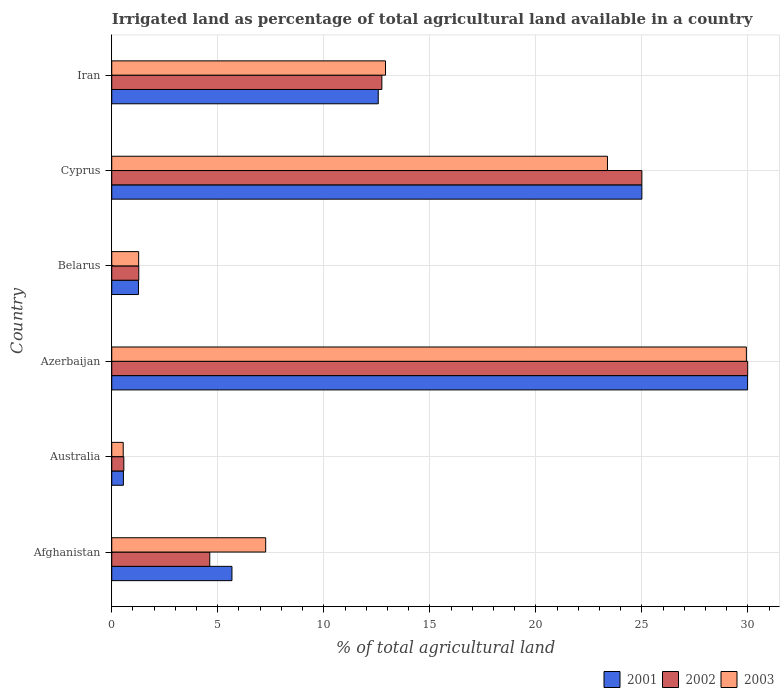How many different coloured bars are there?
Ensure brevity in your answer.  3. Are the number of bars per tick equal to the number of legend labels?
Offer a terse response. Yes. How many bars are there on the 6th tick from the bottom?
Your answer should be compact. 3. What is the label of the 3rd group of bars from the top?
Offer a very short reply. Belarus. What is the percentage of irrigated land in 2003 in Azerbaijan?
Ensure brevity in your answer.  29.93. Across all countries, what is the maximum percentage of irrigated land in 2001?
Ensure brevity in your answer.  29.99. Across all countries, what is the minimum percentage of irrigated land in 2003?
Offer a very short reply. 0.54. In which country was the percentage of irrigated land in 2001 maximum?
Ensure brevity in your answer.  Azerbaijan. What is the total percentage of irrigated land in 2003 in the graph?
Your answer should be compact. 75.29. What is the difference between the percentage of irrigated land in 2002 in Belarus and that in Cyprus?
Make the answer very short. -23.73. What is the difference between the percentage of irrigated land in 2001 in Azerbaijan and the percentage of irrigated land in 2003 in Iran?
Offer a terse response. 17.08. What is the average percentage of irrigated land in 2002 per country?
Offer a very short reply. 12.37. What is the difference between the percentage of irrigated land in 2002 and percentage of irrigated land in 2001 in Belarus?
Offer a terse response. 0.01. What is the ratio of the percentage of irrigated land in 2002 in Afghanistan to that in Iran?
Your answer should be very brief. 0.36. Is the percentage of irrigated land in 2001 in Australia less than that in Azerbaijan?
Offer a terse response. Yes. What is the difference between the highest and the second highest percentage of irrigated land in 2003?
Your answer should be very brief. 6.55. What is the difference between the highest and the lowest percentage of irrigated land in 2002?
Your answer should be compact. 29.42. Is the sum of the percentage of irrigated land in 2003 in Australia and Iran greater than the maximum percentage of irrigated land in 2002 across all countries?
Keep it short and to the point. No. What does the 2nd bar from the top in Australia represents?
Offer a very short reply. 2002. Is it the case that in every country, the sum of the percentage of irrigated land in 2001 and percentage of irrigated land in 2003 is greater than the percentage of irrigated land in 2002?
Keep it short and to the point. Yes. How many bars are there?
Give a very brief answer. 18. Are all the bars in the graph horizontal?
Provide a succinct answer. Yes. What is the difference between two consecutive major ticks on the X-axis?
Your answer should be compact. 5. Are the values on the major ticks of X-axis written in scientific E-notation?
Give a very brief answer. No. Does the graph contain any zero values?
Give a very brief answer. No. Does the graph contain grids?
Your answer should be very brief. Yes. Where does the legend appear in the graph?
Ensure brevity in your answer.  Bottom right. How many legend labels are there?
Ensure brevity in your answer.  3. What is the title of the graph?
Give a very brief answer. Irrigated land as percentage of total agricultural land available in a country. Does "2012" appear as one of the legend labels in the graph?
Offer a very short reply. No. What is the label or title of the X-axis?
Give a very brief answer. % of total agricultural land. What is the label or title of the Y-axis?
Give a very brief answer. Country. What is the % of total agricultural land in 2001 in Afghanistan?
Keep it short and to the point. 5.67. What is the % of total agricultural land in 2002 in Afghanistan?
Give a very brief answer. 4.62. What is the % of total agricultural land of 2003 in Afghanistan?
Offer a very short reply. 7.26. What is the % of total agricultural land of 2001 in Australia?
Provide a short and direct response. 0.55. What is the % of total agricultural land of 2002 in Australia?
Your answer should be compact. 0.57. What is the % of total agricultural land in 2003 in Australia?
Your answer should be very brief. 0.54. What is the % of total agricultural land of 2001 in Azerbaijan?
Offer a terse response. 29.99. What is the % of total agricultural land in 2002 in Azerbaijan?
Your response must be concise. 29.99. What is the % of total agricultural land in 2003 in Azerbaijan?
Provide a succinct answer. 29.93. What is the % of total agricultural land of 2001 in Belarus?
Your response must be concise. 1.26. What is the % of total agricultural land in 2002 in Belarus?
Keep it short and to the point. 1.27. What is the % of total agricultural land of 2003 in Belarus?
Make the answer very short. 1.27. What is the % of total agricultural land of 2001 in Cyprus?
Your response must be concise. 25. What is the % of total agricultural land in 2002 in Cyprus?
Keep it short and to the point. 25. What is the % of total agricultural land in 2003 in Cyprus?
Give a very brief answer. 23.38. What is the % of total agricultural land in 2001 in Iran?
Provide a short and direct response. 12.57. What is the % of total agricultural land in 2002 in Iran?
Offer a very short reply. 12.74. What is the % of total agricultural land in 2003 in Iran?
Make the answer very short. 12.91. Across all countries, what is the maximum % of total agricultural land in 2001?
Give a very brief answer. 29.99. Across all countries, what is the maximum % of total agricultural land of 2002?
Provide a short and direct response. 29.99. Across all countries, what is the maximum % of total agricultural land of 2003?
Your answer should be compact. 29.93. Across all countries, what is the minimum % of total agricultural land in 2001?
Your answer should be very brief. 0.55. Across all countries, what is the minimum % of total agricultural land in 2002?
Your answer should be compact. 0.57. Across all countries, what is the minimum % of total agricultural land of 2003?
Keep it short and to the point. 0.54. What is the total % of total agricultural land in 2001 in the graph?
Provide a short and direct response. 75.03. What is the total % of total agricultural land of 2002 in the graph?
Offer a terse response. 74.19. What is the total % of total agricultural land of 2003 in the graph?
Give a very brief answer. 75.29. What is the difference between the % of total agricultural land in 2001 in Afghanistan and that in Australia?
Provide a succinct answer. 5.12. What is the difference between the % of total agricultural land in 2002 in Afghanistan and that in Australia?
Keep it short and to the point. 4.05. What is the difference between the % of total agricultural land in 2003 in Afghanistan and that in Australia?
Your answer should be compact. 6.72. What is the difference between the % of total agricultural land in 2001 in Afghanistan and that in Azerbaijan?
Your answer should be compact. -24.32. What is the difference between the % of total agricultural land in 2002 in Afghanistan and that in Azerbaijan?
Keep it short and to the point. -25.37. What is the difference between the % of total agricultural land of 2003 in Afghanistan and that in Azerbaijan?
Offer a very short reply. -22.67. What is the difference between the % of total agricultural land of 2001 in Afghanistan and that in Belarus?
Provide a short and direct response. 4.41. What is the difference between the % of total agricultural land of 2002 in Afghanistan and that in Belarus?
Make the answer very short. 3.35. What is the difference between the % of total agricultural land of 2003 in Afghanistan and that in Belarus?
Make the answer very short. 5.99. What is the difference between the % of total agricultural land in 2001 in Afghanistan and that in Cyprus?
Offer a very short reply. -19.33. What is the difference between the % of total agricultural land of 2002 in Afghanistan and that in Cyprus?
Offer a very short reply. -20.38. What is the difference between the % of total agricultural land in 2003 in Afghanistan and that in Cyprus?
Provide a succinct answer. -16.12. What is the difference between the % of total agricultural land of 2001 in Afghanistan and that in Iran?
Ensure brevity in your answer.  -6.9. What is the difference between the % of total agricultural land in 2002 in Afghanistan and that in Iran?
Offer a terse response. -8.12. What is the difference between the % of total agricultural land in 2003 in Afghanistan and that in Iran?
Ensure brevity in your answer.  -5.65. What is the difference between the % of total agricultural land of 2001 in Australia and that in Azerbaijan?
Your answer should be compact. -29.44. What is the difference between the % of total agricultural land of 2002 in Australia and that in Azerbaijan?
Give a very brief answer. -29.42. What is the difference between the % of total agricultural land in 2003 in Australia and that in Azerbaijan?
Provide a short and direct response. -29.39. What is the difference between the % of total agricultural land in 2001 in Australia and that in Belarus?
Make the answer very short. -0.71. What is the difference between the % of total agricultural land in 2002 in Australia and that in Belarus?
Offer a terse response. -0.7. What is the difference between the % of total agricultural land of 2003 in Australia and that in Belarus?
Ensure brevity in your answer.  -0.73. What is the difference between the % of total agricultural land in 2001 in Australia and that in Cyprus?
Ensure brevity in your answer.  -24.45. What is the difference between the % of total agricultural land in 2002 in Australia and that in Cyprus?
Keep it short and to the point. -24.43. What is the difference between the % of total agricultural land in 2003 in Australia and that in Cyprus?
Provide a short and direct response. -22.84. What is the difference between the % of total agricultural land in 2001 in Australia and that in Iran?
Give a very brief answer. -12.02. What is the difference between the % of total agricultural land in 2002 in Australia and that in Iran?
Keep it short and to the point. -12.17. What is the difference between the % of total agricultural land in 2003 in Australia and that in Iran?
Offer a very short reply. -12.37. What is the difference between the % of total agricultural land of 2001 in Azerbaijan and that in Belarus?
Your answer should be very brief. 28.73. What is the difference between the % of total agricultural land in 2002 in Azerbaijan and that in Belarus?
Offer a terse response. 28.72. What is the difference between the % of total agricultural land of 2003 in Azerbaijan and that in Belarus?
Provide a succinct answer. 28.66. What is the difference between the % of total agricultural land of 2001 in Azerbaijan and that in Cyprus?
Your answer should be compact. 4.99. What is the difference between the % of total agricultural land in 2002 in Azerbaijan and that in Cyprus?
Your response must be concise. 4.99. What is the difference between the % of total agricultural land in 2003 in Azerbaijan and that in Cyprus?
Give a very brief answer. 6.55. What is the difference between the % of total agricultural land in 2001 in Azerbaijan and that in Iran?
Offer a very short reply. 17.42. What is the difference between the % of total agricultural land of 2002 in Azerbaijan and that in Iran?
Give a very brief answer. 17.25. What is the difference between the % of total agricultural land of 2003 in Azerbaijan and that in Iran?
Ensure brevity in your answer.  17.02. What is the difference between the % of total agricultural land of 2001 in Belarus and that in Cyprus?
Your answer should be compact. -23.74. What is the difference between the % of total agricultural land in 2002 in Belarus and that in Cyprus?
Your response must be concise. -23.73. What is the difference between the % of total agricultural land of 2003 in Belarus and that in Cyprus?
Ensure brevity in your answer.  -22.11. What is the difference between the % of total agricultural land in 2001 in Belarus and that in Iran?
Your answer should be very brief. -11.31. What is the difference between the % of total agricultural land in 2002 in Belarus and that in Iran?
Ensure brevity in your answer.  -11.46. What is the difference between the % of total agricultural land in 2003 in Belarus and that in Iran?
Keep it short and to the point. -11.64. What is the difference between the % of total agricultural land in 2001 in Cyprus and that in Iran?
Ensure brevity in your answer.  12.43. What is the difference between the % of total agricultural land of 2002 in Cyprus and that in Iran?
Make the answer very short. 12.26. What is the difference between the % of total agricultural land in 2003 in Cyprus and that in Iran?
Your answer should be very brief. 10.47. What is the difference between the % of total agricultural land of 2001 in Afghanistan and the % of total agricultural land of 2002 in Australia?
Provide a short and direct response. 5.1. What is the difference between the % of total agricultural land in 2001 in Afghanistan and the % of total agricultural land in 2003 in Australia?
Offer a very short reply. 5.13. What is the difference between the % of total agricultural land of 2002 in Afghanistan and the % of total agricultural land of 2003 in Australia?
Make the answer very short. 4.08. What is the difference between the % of total agricultural land in 2001 in Afghanistan and the % of total agricultural land in 2002 in Azerbaijan?
Ensure brevity in your answer.  -24.32. What is the difference between the % of total agricultural land in 2001 in Afghanistan and the % of total agricultural land in 2003 in Azerbaijan?
Make the answer very short. -24.26. What is the difference between the % of total agricultural land in 2002 in Afghanistan and the % of total agricultural land in 2003 in Azerbaijan?
Ensure brevity in your answer.  -25.31. What is the difference between the % of total agricultural land of 2001 in Afghanistan and the % of total agricultural land of 2002 in Belarus?
Keep it short and to the point. 4.39. What is the difference between the % of total agricultural land of 2001 in Afghanistan and the % of total agricultural land of 2003 in Belarus?
Make the answer very short. 4.4. What is the difference between the % of total agricultural land of 2002 in Afghanistan and the % of total agricultural land of 2003 in Belarus?
Offer a very short reply. 3.35. What is the difference between the % of total agricultural land of 2001 in Afghanistan and the % of total agricultural land of 2002 in Cyprus?
Your answer should be very brief. -19.33. What is the difference between the % of total agricultural land in 2001 in Afghanistan and the % of total agricultural land in 2003 in Cyprus?
Keep it short and to the point. -17.71. What is the difference between the % of total agricultural land of 2002 in Afghanistan and the % of total agricultural land of 2003 in Cyprus?
Your answer should be very brief. -18.75. What is the difference between the % of total agricultural land of 2001 in Afghanistan and the % of total agricultural land of 2002 in Iran?
Your response must be concise. -7.07. What is the difference between the % of total agricultural land of 2001 in Afghanistan and the % of total agricultural land of 2003 in Iran?
Offer a very short reply. -7.24. What is the difference between the % of total agricultural land of 2002 in Afghanistan and the % of total agricultural land of 2003 in Iran?
Your answer should be very brief. -8.29. What is the difference between the % of total agricultural land of 2001 in Australia and the % of total agricultural land of 2002 in Azerbaijan?
Ensure brevity in your answer.  -29.44. What is the difference between the % of total agricultural land of 2001 in Australia and the % of total agricultural land of 2003 in Azerbaijan?
Offer a very short reply. -29.38. What is the difference between the % of total agricultural land in 2002 in Australia and the % of total agricultural land in 2003 in Azerbaijan?
Make the answer very short. -29.36. What is the difference between the % of total agricultural land of 2001 in Australia and the % of total agricultural land of 2002 in Belarus?
Provide a succinct answer. -0.72. What is the difference between the % of total agricultural land in 2001 in Australia and the % of total agricultural land in 2003 in Belarus?
Keep it short and to the point. -0.72. What is the difference between the % of total agricultural land in 2002 in Australia and the % of total agricultural land in 2003 in Belarus?
Ensure brevity in your answer.  -0.7. What is the difference between the % of total agricultural land of 2001 in Australia and the % of total agricultural land of 2002 in Cyprus?
Give a very brief answer. -24.45. What is the difference between the % of total agricultural land of 2001 in Australia and the % of total agricultural land of 2003 in Cyprus?
Provide a short and direct response. -22.83. What is the difference between the % of total agricultural land of 2002 in Australia and the % of total agricultural land of 2003 in Cyprus?
Give a very brief answer. -22.81. What is the difference between the % of total agricultural land of 2001 in Australia and the % of total agricultural land of 2002 in Iran?
Provide a short and direct response. -12.19. What is the difference between the % of total agricultural land of 2001 in Australia and the % of total agricultural land of 2003 in Iran?
Keep it short and to the point. -12.36. What is the difference between the % of total agricultural land in 2002 in Australia and the % of total agricultural land in 2003 in Iran?
Offer a terse response. -12.34. What is the difference between the % of total agricultural land of 2001 in Azerbaijan and the % of total agricultural land of 2002 in Belarus?
Your response must be concise. 28.71. What is the difference between the % of total agricultural land in 2001 in Azerbaijan and the % of total agricultural land in 2003 in Belarus?
Ensure brevity in your answer.  28.72. What is the difference between the % of total agricultural land in 2002 in Azerbaijan and the % of total agricultural land in 2003 in Belarus?
Offer a very short reply. 28.72. What is the difference between the % of total agricultural land in 2001 in Azerbaijan and the % of total agricultural land in 2002 in Cyprus?
Keep it short and to the point. 4.99. What is the difference between the % of total agricultural land of 2001 in Azerbaijan and the % of total agricultural land of 2003 in Cyprus?
Ensure brevity in your answer.  6.61. What is the difference between the % of total agricultural land of 2002 in Azerbaijan and the % of total agricultural land of 2003 in Cyprus?
Provide a succinct answer. 6.61. What is the difference between the % of total agricultural land of 2001 in Azerbaijan and the % of total agricultural land of 2002 in Iran?
Ensure brevity in your answer.  17.25. What is the difference between the % of total agricultural land of 2001 in Azerbaijan and the % of total agricultural land of 2003 in Iran?
Keep it short and to the point. 17.08. What is the difference between the % of total agricultural land of 2002 in Azerbaijan and the % of total agricultural land of 2003 in Iran?
Offer a very short reply. 17.08. What is the difference between the % of total agricultural land in 2001 in Belarus and the % of total agricultural land in 2002 in Cyprus?
Offer a very short reply. -23.74. What is the difference between the % of total agricultural land of 2001 in Belarus and the % of total agricultural land of 2003 in Cyprus?
Your answer should be very brief. -22.12. What is the difference between the % of total agricultural land of 2002 in Belarus and the % of total agricultural land of 2003 in Cyprus?
Your answer should be compact. -22.1. What is the difference between the % of total agricultural land of 2001 in Belarus and the % of total agricultural land of 2002 in Iran?
Your answer should be very brief. -11.48. What is the difference between the % of total agricultural land in 2001 in Belarus and the % of total agricultural land in 2003 in Iran?
Make the answer very short. -11.65. What is the difference between the % of total agricultural land of 2002 in Belarus and the % of total agricultural land of 2003 in Iran?
Offer a very short reply. -11.64. What is the difference between the % of total agricultural land in 2001 in Cyprus and the % of total agricultural land in 2002 in Iran?
Provide a succinct answer. 12.26. What is the difference between the % of total agricultural land in 2001 in Cyprus and the % of total agricultural land in 2003 in Iran?
Give a very brief answer. 12.09. What is the difference between the % of total agricultural land in 2002 in Cyprus and the % of total agricultural land in 2003 in Iran?
Your answer should be compact. 12.09. What is the average % of total agricultural land in 2001 per country?
Ensure brevity in your answer.  12.51. What is the average % of total agricultural land in 2002 per country?
Give a very brief answer. 12.37. What is the average % of total agricultural land of 2003 per country?
Offer a very short reply. 12.55. What is the difference between the % of total agricultural land in 2001 and % of total agricultural land in 2002 in Afghanistan?
Make the answer very short. 1.05. What is the difference between the % of total agricultural land of 2001 and % of total agricultural land of 2003 in Afghanistan?
Provide a short and direct response. -1.59. What is the difference between the % of total agricultural land in 2002 and % of total agricultural land in 2003 in Afghanistan?
Your answer should be very brief. -2.64. What is the difference between the % of total agricultural land of 2001 and % of total agricultural land of 2002 in Australia?
Ensure brevity in your answer.  -0.02. What is the difference between the % of total agricultural land in 2001 and % of total agricultural land in 2003 in Australia?
Keep it short and to the point. 0.01. What is the difference between the % of total agricultural land of 2002 and % of total agricultural land of 2003 in Australia?
Offer a terse response. 0.03. What is the difference between the % of total agricultural land of 2001 and % of total agricultural land of 2002 in Azerbaijan?
Ensure brevity in your answer.  -0. What is the difference between the % of total agricultural land in 2001 and % of total agricultural land in 2003 in Azerbaijan?
Give a very brief answer. 0.06. What is the difference between the % of total agricultural land in 2002 and % of total agricultural land in 2003 in Azerbaijan?
Your response must be concise. 0.06. What is the difference between the % of total agricultural land in 2001 and % of total agricultural land in 2002 in Belarus?
Offer a very short reply. -0.01. What is the difference between the % of total agricultural land of 2001 and % of total agricultural land of 2003 in Belarus?
Offer a terse response. -0.01. What is the difference between the % of total agricultural land in 2002 and % of total agricultural land in 2003 in Belarus?
Your response must be concise. 0.01. What is the difference between the % of total agricultural land of 2001 and % of total agricultural land of 2002 in Cyprus?
Make the answer very short. 0. What is the difference between the % of total agricultural land of 2001 and % of total agricultural land of 2003 in Cyprus?
Ensure brevity in your answer.  1.62. What is the difference between the % of total agricultural land of 2002 and % of total agricultural land of 2003 in Cyprus?
Give a very brief answer. 1.62. What is the difference between the % of total agricultural land in 2001 and % of total agricultural land in 2002 in Iran?
Your answer should be very brief. -0.17. What is the difference between the % of total agricultural land in 2001 and % of total agricultural land in 2003 in Iran?
Your response must be concise. -0.34. What is the difference between the % of total agricultural land of 2002 and % of total agricultural land of 2003 in Iran?
Provide a short and direct response. -0.17. What is the ratio of the % of total agricultural land in 2001 in Afghanistan to that in Australia?
Make the answer very short. 10.31. What is the ratio of the % of total agricultural land of 2002 in Afghanistan to that in Australia?
Offer a very short reply. 8.12. What is the ratio of the % of total agricultural land of 2003 in Afghanistan to that in Australia?
Offer a terse response. 13.42. What is the ratio of the % of total agricultural land in 2001 in Afghanistan to that in Azerbaijan?
Provide a succinct answer. 0.19. What is the ratio of the % of total agricultural land of 2002 in Afghanistan to that in Azerbaijan?
Provide a succinct answer. 0.15. What is the ratio of the % of total agricultural land of 2003 in Afghanistan to that in Azerbaijan?
Provide a succinct answer. 0.24. What is the ratio of the % of total agricultural land of 2001 in Afghanistan to that in Belarus?
Ensure brevity in your answer.  4.5. What is the ratio of the % of total agricultural land in 2002 in Afghanistan to that in Belarus?
Ensure brevity in your answer.  3.63. What is the ratio of the % of total agricultural land in 2003 in Afghanistan to that in Belarus?
Offer a terse response. 5.72. What is the ratio of the % of total agricultural land in 2001 in Afghanistan to that in Cyprus?
Offer a very short reply. 0.23. What is the ratio of the % of total agricultural land in 2002 in Afghanistan to that in Cyprus?
Your answer should be compact. 0.18. What is the ratio of the % of total agricultural land in 2003 in Afghanistan to that in Cyprus?
Ensure brevity in your answer.  0.31. What is the ratio of the % of total agricultural land of 2001 in Afghanistan to that in Iran?
Offer a terse response. 0.45. What is the ratio of the % of total agricultural land in 2002 in Afghanistan to that in Iran?
Make the answer very short. 0.36. What is the ratio of the % of total agricultural land in 2003 in Afghanistan to that in Iran?
Offer a terse response. 0.56. What is the ratio of the % of total agricultural land in 2001 in Australia to that in Azerbaijan?
Your answer should be very brief. 0.02. What is the ratio of the % of total agricultural land in 2002 in Australia to that in Azerbaijan?
Ensure brevity in your answer.  0.02. What is the ratio of the % of total agricultural land in 2003 in Australia to that in Azerbaijan?
Offer a very short reply. 0.02. What is the ratio of the % of total agricultural land of 2001 in Australia to that in Belarus?
Give a very brief answer. 0.44. What is the ratio of the % of total agricultural land in 2002 in Australia to that in Belarus?
Your answer should be compact. 0.45. What is the ratio of the % of total agricultural land of 2003 in Australia to that in Belarus?
Your response must be concise. 0.43. What is the ratio of the % of total agricultural land of 2001 in Australia to that in Cyprus?
Give a very brief answer. 0.02. What is the ratio of the % of total agricultural land in 2002 in Australia to that in Cyprus?
Provide a succinct answer. 0.02. What is the ratio of the % of total agricultural land in 2003 in Australia to that in Cyprus?
Give a very brief answer. 0.02. What is the ratio of the % of total agricultural land in 2001 in Australia to that in Iran?
Your answer should be compact. 0.04. What is the ratio of the % of total agricultural land of 2002 in Australia to that in Iran?
Keep it short and to the point. 0.04. What is the ratio of the % of total agricultural land in 2003 in Australia to that in Iran?
Make the answer very short. 0.04. What is the ratio of the % of total agricultural land in 2001 in Azerbaijan to that in Belarus?
Ensure brevity in your answer.  23.8. What is the ratio of the % of total agricultural land in 2002 in Azerbaijan to that in Belarus?
Give a very brief answer. 23.54. What is the ratio of the % of total agricultural land in 2003 in Azerbaijan to that in Belarus?
Offer a terse response. 23.59. What is the ratio of the % of total agricultural land of 2001 in Azerbaijan to that in Cyprus?
Offer a very short reply. 1.2. What is the ratio of the % of total agricultural land of 2002 in Azerbaijan to that in Cyprus?
Provide a succinct answer. 1.2. What is the ratio of the % of total agricultural land in 2003 in Azerbaijan to that in Cyprus?
Your answer should be very brief. 1.28. What is the ratio of the % of total agricultural land of 2001 in Azerbaijan to that in Iran?
Provide a short and direct response. 2.39. What is the ratio of the % of total agricultural land in 2002 in Azerbaijan to that in Iran?
Provide a succinct answer. 2.35. What is the ratio of the % of total agricultural land of 2003 in Azerbaijan to that in Iran?
Your response must be concise. 2.32. What is the ratio of the % of total agricultural land of 2001 in Belarus to that in Cyprus?
Give a very brief answer. 0.05. What is the ratio of the % of total agricultural land in 2002 in Belarus to that in Cyprus?
Your answer should be compact. 0.05. What is the ratio of the % of total agricultural land in 2003 in Belarus to that in Cyprus?
Offer a terse response. 0.05. What is the ratio of the % of total agricultural land of 2001 in Belarus to that in Iran?
Provide a short and direct response. 0.1. What is the ratio of the % of total agricultural land in 2003 in Belarus to that in Iran?
Make the answer very short. 0.1. What is the ratio of the % of total agricultural land of 2001 in Cyprus to that in Iran?
Offer a terse response. 1.99. What is the ratio of the % of total agricultural land of 2002 in Cyprus to that in Iran?
Provide a succinct answer. 1.96. What is the ratio of the % of total agricultural land of 2003 in Cyprus to that in Iran?
Provide a succinct answer. 1.81. What is the difference between the highest and the second highest % of total agricultural land in 2001?
Offer a terse response. 4.99. What is the difference between the highest and the second highest % of total agricultural land in 2002?
Provide a succinct answer. 4.99. What is the difference between the highest and the second highest % of total agricultural land of 2003?
Ensure brevity in your answer.  6.55. What is the difference between the highest and the lowest % of total agricultural land of 2001?
Your response must be concise. 29.44. What is the difference between the highest and the lowest % of total agricultural land of 2002?
Provide a short and direct response. 29.42. What is the difference between the highest and the lowest % of total agricultural land in 2003?
Ensure brevity in your answer.  29.39. 